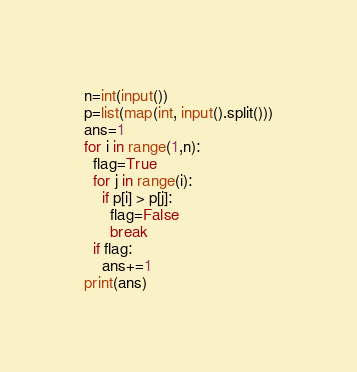Convert code to text. <code><loc_0><loc_0><loc_500><loc_500><_Python_>n=int(input())
p=list(map(int, input().split()))
ans=1
for i in range(1,n):
  flag=True
  for j in range(i):
    if p[i] > p[j]:
      flag=False
      break
  if flag:
    ans+=1
print(ans)</code> 